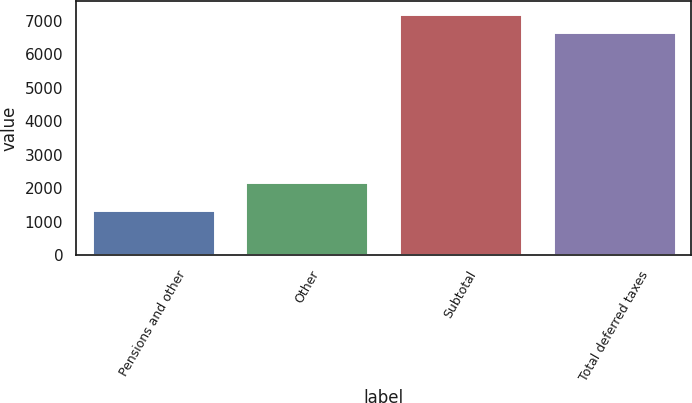Convert chart. <chart><loc_0><loc_0><loc_500><loc_500><bar_chart><fcel>Pensions and other<fcel>Other<fcel>Subtotal<fcel>Total deferred taxes<nl><fcel>1345.7<fcel>2201.1<fcel>7213.96<fcel>6662.7<nl></chart> 